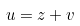Convert formula to latex. <formula><loc_0><loc_0><loc_500><loc_500>u = z + v</formula> 